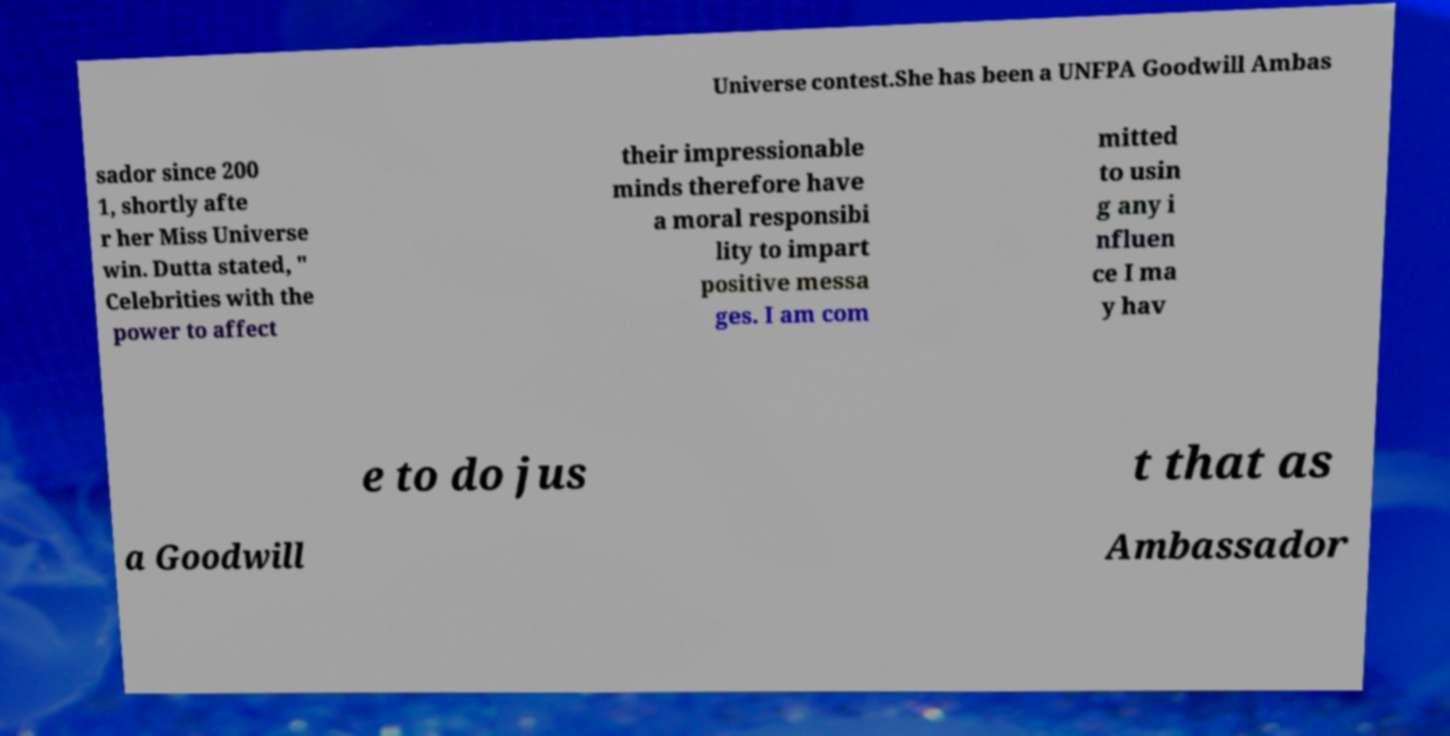Please read and relay the text visible in this image. What does it say? Universe contest.She has been a UNFPA Goodwill Ambas sador since 200 1, shortly afte r her Miss Universe win. Dutta stated, " Celebrities with the power to affect their impressionable minds therefore have a moral responsibi lity to impart positive messa ges. I am com mitted to usin g any i nfluen ce I ma y hav e to do jus t that as a Goodwill Ambassador 